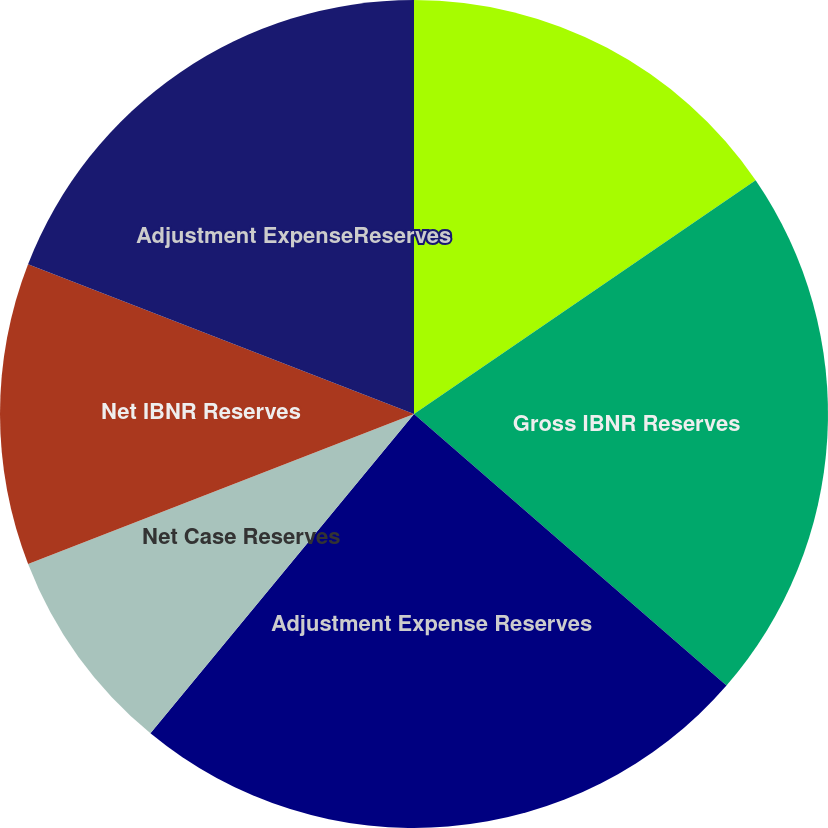<chart> <loc_0><loc_0><loc_500><loc_500><pie_chart><fcel>Gross Case Reserves<fcel>Gross IBNR Reserves<fcel>Adjustment Expense Reserves<fcel>Net Case Reserves<fcel>Net IBNR Reserves<fcel>Adjustment ExpenseReserves<nl><fcel>15.45%<fcel>20.94%<fcel>24.6%<fcel>8.12%<fcel>11.79%<fcel>19.11%<nl></chart> 